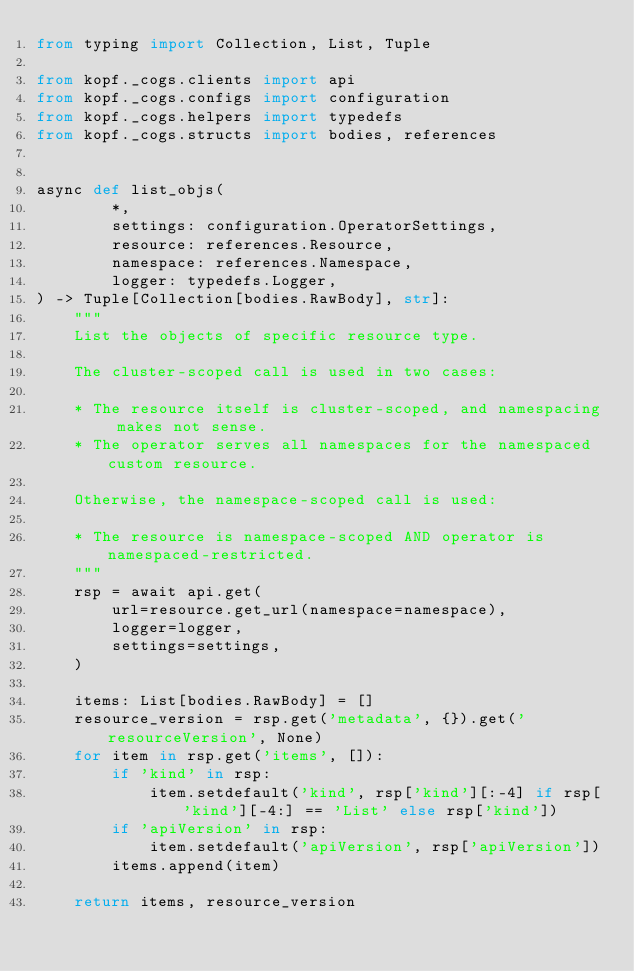<code> <loc_0><loc_0><loc_500><loc_500><_Python_>from typing import Collection, List, Tuple

from kopf._cogs.clients import api
from kopf._cogs.configs import configuration
from kopf._cogs.helpers import typedefs
from kopf._cogs.structs import bodies, references


async def list_objs(
        *,
        settings: configuration.OperatorSettings,
        resource: references.Resource,
        namespace: references.Namespace,
        logger: typedefs.Logger,
) -> Tuple[Collection[bodies.RawBody], str]:
    """
    List the objects of specific resource type.

    The cluster-scoped call is used in two cases:

    * The resource itself is cluster-scoped, and namespacing makes not sense.
    * The operator serves all namespaces for the namespaced custom resource.

    Otherwise, the namespace-scoped call is used:

    * The resource is namespace-scoped AND operator is namespaced-restricted.
    """
    rsp = await api.get(
        url=resource.get_url(namespace=namespace),
        logger=logger,
        settings=settings,
    )

    items: List[bodies.RawBody] = []
    resource_version = rsp.get('metadata', {}).get('resourceVersion', None)
    for item in rsp.get('items', []):
        if 'kind' in rsp:
            item.setdefault('kind', rsp['kind'][:-4] if rsp['kind'][-4:] == 'List' else rsp['kind'])
        if 'apiVersion' in rsp:
            item.setdefault('apiVersion', rsp['apiVersion'])
        items.append(item)

    return items, resource_version
</code> 